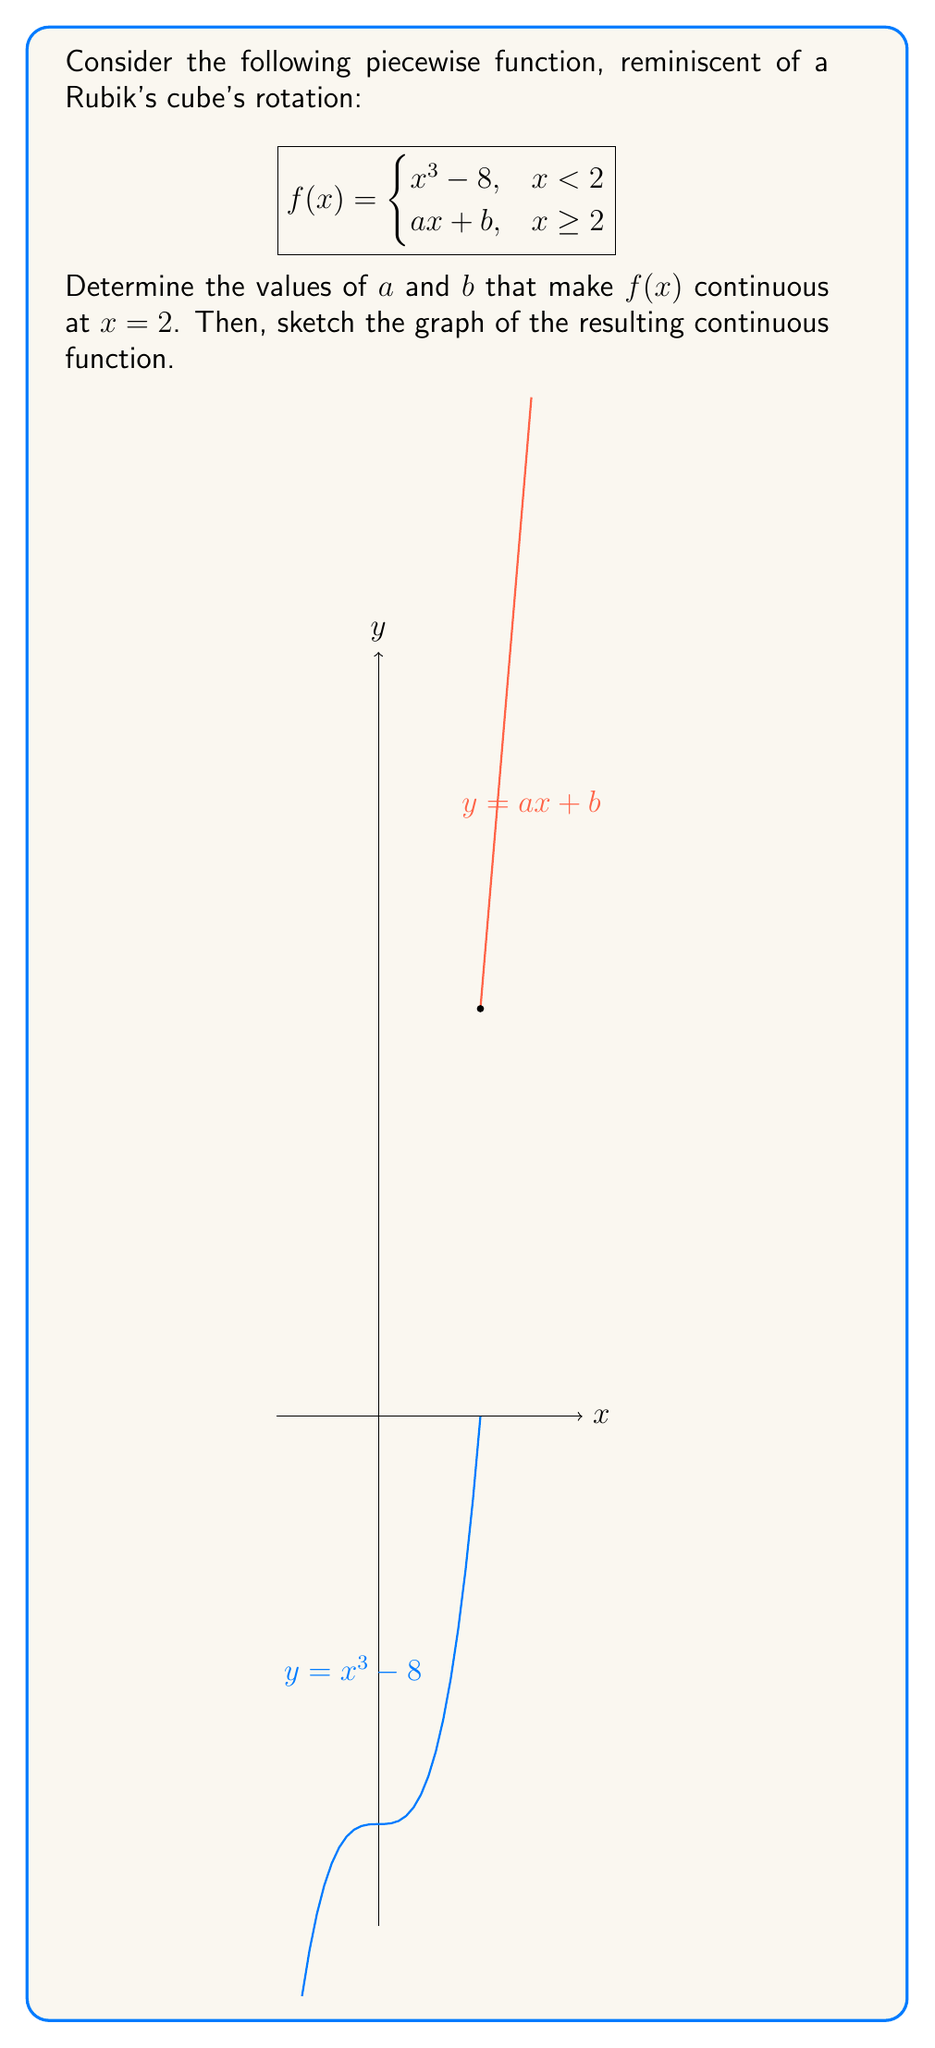Solve this math problem. To determine the continuity of a piecewise function, we need to ensure that the function is continuous from both sides at the point where the pieces meet. In this case, we need to make the function continuous at $x = 2$.

Step 1: Evaluate the left-hand limit as x approaches 2.
$$\lim_{x \to 2^-} f(x) = \lim_{x \to 2^-} (x^3 - 8) = 2^3 - 8 = 8 - 8 = 0$$

Step 2: For the function to be continuous, the right-hand limit must equal the left-hand limit.
$$\lim_{x \to 2^+} f(x) = \lim_{x \to 2^+} (ax + b) = 2a + b$$

Step 3: Set up the continuity equation.
$$\lim_{x \to 2^-} f(x) = \lim_{x \to 2^+} f(x)$$
$$0 = 2a + b$$

Step 4: We also need the function to be differentiable at $x = 2$ for smoothness. The derivative of $x^3 - 8$ at $x = 2$ is:
$$\frac{d}{dx}(x^3 - 8) = 3x^2$$
At $x = 2$, this equals $3(2^2) = 12$.

Step 5: Set up the differentiability equation.
$$12 = a$$

Step 6: Solve the system of equations.
From Step 5: $a = 12$
Substituting into the equation from Step 3: $0 = 2(12) + b$
Solving for $b$: $b = -24$

Therefore, $a = 12$ and $b = -24$.

The resulting continuous function is:

$$f(x) = \begin{cases}
x^3 - 8, & x < 2 \\
12x - 24, & x \geq 2
\end{cases}$$

The graph shows a smooth transition at $x = 2$, resembling a corner piece of a Rubik's cube smoothly rotating into place.
Answer: $a = 12$, $b = -24$ 